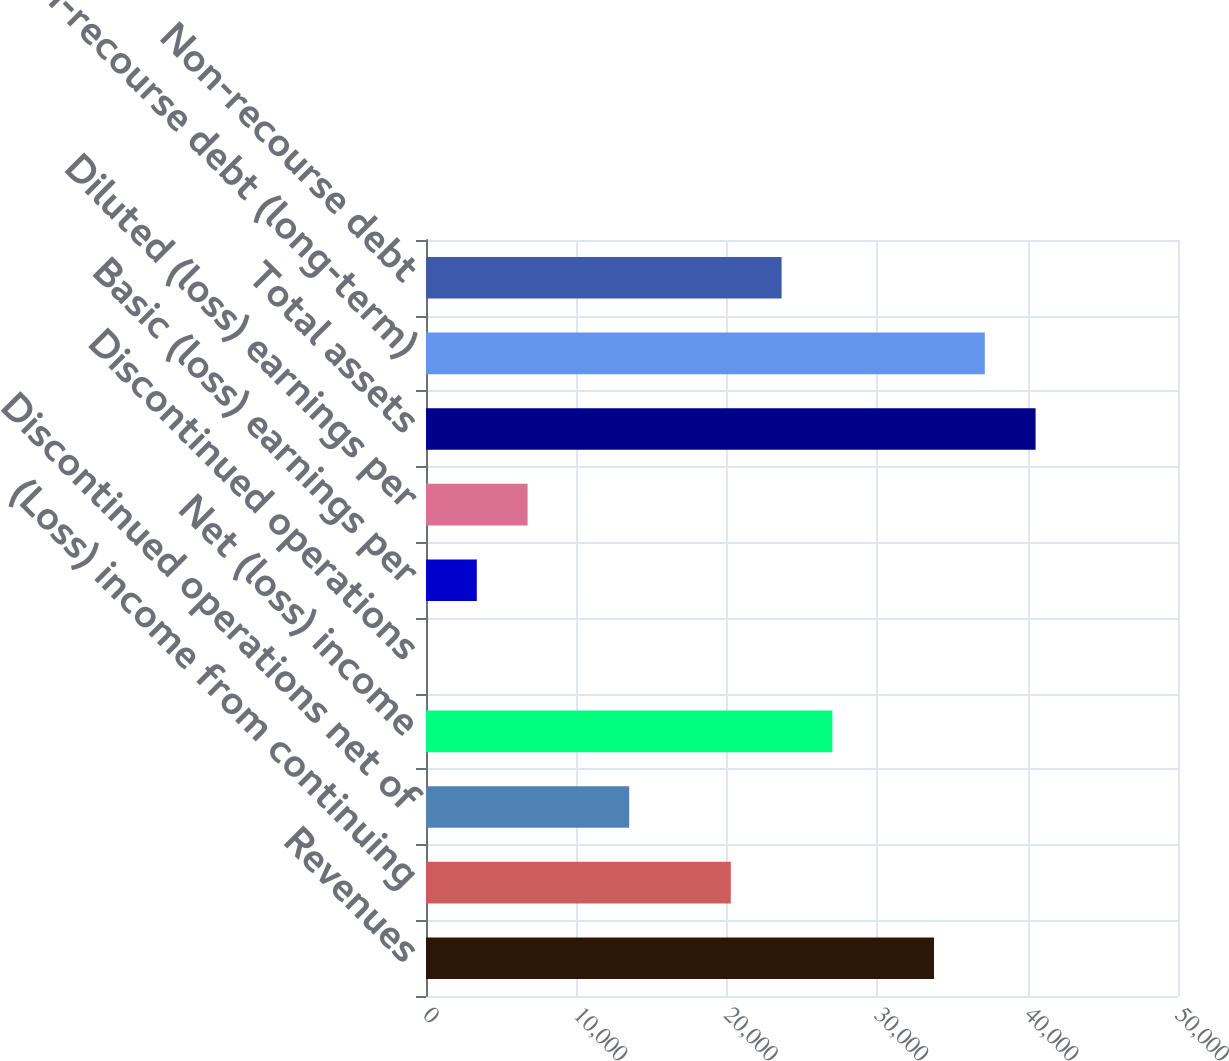<chart> <loc_0><loc_0><loc_500><loc_500><bar_chart><fcel>Revenues<fcel>(Loss) income from continuing<fcel>Discontinued operations net of<fcel>Net (loss) income<fcel>Discontinued operations<fcel>Basic (loss) earnings per<fcel>Diluted (loss) earnings per<fcel>Total assets<fcel>Non-recourse debt (long-term)<fcel>Non-recourse debt<nl><fcel>33776<fcel>20266<fcel>13511<fcel>27021<fcel>1.05<fcel>3378.55<fcel>6756.05<fcel>40531<fcel>37153.5<fcel>23643.5<nl></chart> 